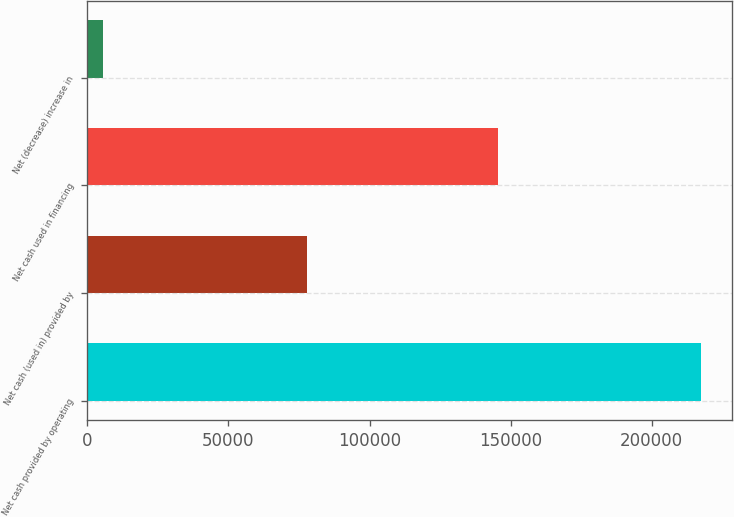Convert chart to OTSL. <chart><loc_0><loc_0><loc_500><loc_500><bar_chart><fcel>Net cash provided by operating<fcel>Net cash (used in) provided by<fcel>Net cash used in financing<fcel>Net (decrease) increase in<nl><fcel>217633<fcel>77723<fcel>145569<fcel>5659<nl></chart> 